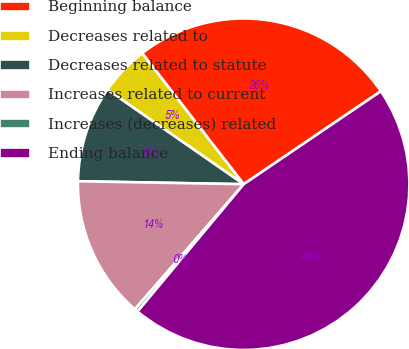Convert chart to OTSL. <chart><loc_0><loc_0><loc_500><loc_500><pie_chart><fcel>Beginning balance<fcel>Decreases related to<fcel>Decreases related to statute<fcel>Increases related to current<fcel>Increases (decreases) related<fcel>Ending balance<nl><fcel>26.01%<fcel>4.85%<fcel>9.37%<fcel>13.89%<fcel>0.33%<fcel>45.54%<nl></chart> 